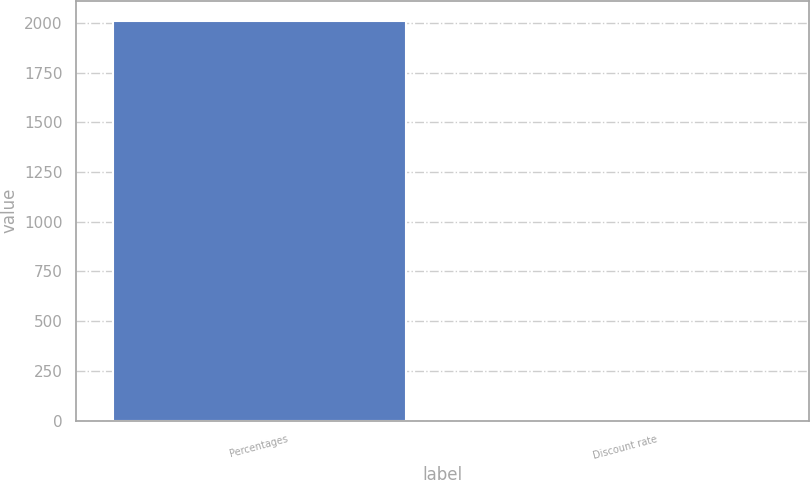Convert chart to OTSL. <chart><loc_0><loc_0><loc_500><loc_500><bar_chart><fcel>Percentages<fcel>Discount rate<nl><fcel>2011<fcel>4.54<nl></chart> 